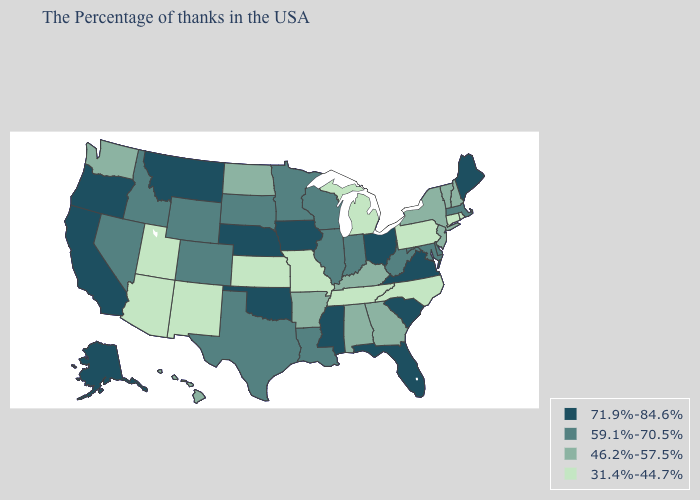Which states have the lowest value in the MidWest?
Keep it brief. Michigan, Missouri, Kansas. What is the lowest value in the South?
Short answer required. 31.4%-44.7%. Does the map have missing data?
Concise answer only. No. Name the states that have a value in the range 59.1%-70.5%?
Short answer required. Massachusetts, Delaware, Maryland, West Virginia, Indiana, Wisconsin, Illinois, Louisiana, Minnesota, Texas, South Dakota, Wyoming, Colorado, Idaho, Nevada. Name the states that have a value in the range 59.1%-70.5%?
Give a very brief answer. Massachusetts, Delaware, Maryland, West Virginia, Indiana, Wisconsin, Illinois, Louisiana, Minnesota, Texas, South Dakota, Wyoming, Colorado, Idaho, Nevada. Which states have the lowest value in the USA?
Answer briefly. Rhode Island, Connecticut, Pennsylvania, North Carolina, Michigan, Tennessee, Missouri, Kansas, New Mexico, Utah, Arizona. Name the states that have a value in the range 46.2%-57.5%?
Short answer required. New Hampshire, Vermont, New York, New Jersey, Georgia, Kentucky, Alabama, Arkansas, North Dakota, Washington, Hawaii. Does the map have missing data?
Write a very short answer. No. Is the legend a continuous bar?
Write a very short answer. No. Name the states that have a value in the range 71.9%-84.6%?
Short answer required. Maine, Virginia, South Carolina, Ohio, Florida, Mississippi, Iowa, Nebraska, Oklahoma, Montana, California, Oregon, Alaska. What is the lowest value in the MidWest?
Answer briefly. 31.4%-44.7%. Name the states that have a value in the range 59.1%-70.5%?
Answer briefly. Massachusetts, Delaware, Maryland, West Virginia, Indiana, Wisconsin, Illinois, Louisiana, Minnesota, Texas, South Dakota, Wyoming, Colorado, Idaho, Nevada. What is the value of Wyoming?
Answer briefly. 59.1%-70.5%. Does Idaho have a higher value than Michigan?
Quick response, please. Yes. Does the map have missing data?
Answer briefly. No. 